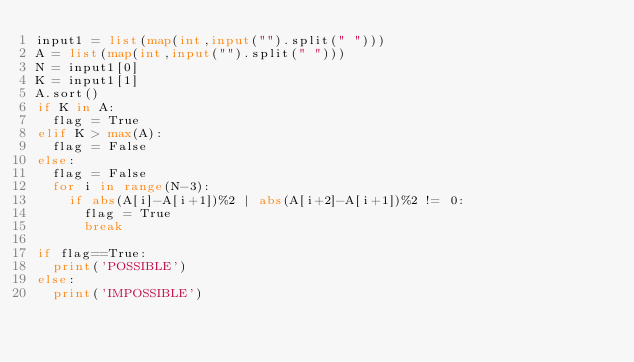<code> <loc_0><loc_0><loc_500><loc_500><_Python_>input1 = list(map(int,input("").split(" ")))
A = list(map(int,input("").split(" ")))
N = input1[0]
K = input1[1]
A.sort()
if K in A:
	flag = True
elif K > max(A):
	flag = False
else:
	flag = False
	for i in range(N-3):
		if abs(A[i]-A[i+1])%2 | abs(A[i+2]-A[i+1])%2 != 0:
			flag = True
			break

if flag==True:
	print('POSSIBLE')
else:
	print('IMPOSSIBLE')</code> 